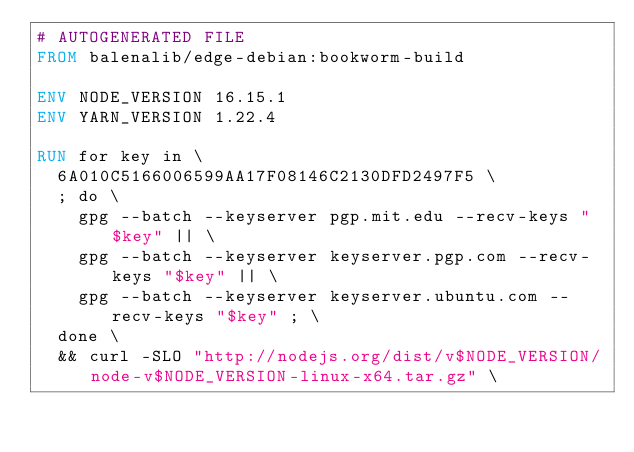<code> <loc_0><loc_0><loc_500><loc_500><_Dockerfile_># AUTOGENERATED FILE
FROM balenalib/edge-debian:bookworm-build

ENV NODE_VERSION 16.15.1
ENV YARN_VERSION 1.22.4

RUN for key in \
	6A010C5166006599AA17F08146C2130DFD2497F5 \
	; do \
		gpg --batch --keyserver pgp.mit.edu --recv-keys "$key" || \
		gpg --batch --keyserver keyserver.pgp.com --recv-keys "$key" || \
		gpg --batch --keyserver keyserver.ubuntu.com --recv-keys "$key" ; \
	done \
	&& curl -SLO "http://nodejs.org/dist/v$NODE_VERSION/node-v$NODE_VERSION-linux-x64.tar.gz" \</code> 